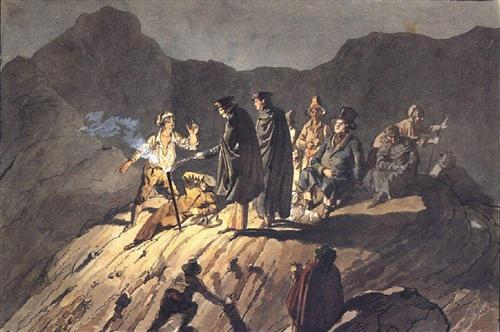Imagine this scene is part of a larger narrative. How would you continue the story? In the aftermath of their confrontation, a pact is formed between the conflicting parties, pledging to work together to uncover the secrets hidden within the rocky cliff. Sir Nathaniel leads the group into an expansive cavern, its entrance concealed by years of erosion. Torches flicker against the damp walls as they delve deeper, revealing ancient carvings and long-forgotten treasure troves. However, as they progress, they face a series of challenges: collapsing tunnels, subterranean monsters awakened from their slumber, and ancient curses guarding the treasures. The journey tests their resolve, alliances are strained, and some pay a high price for the pursuit of knowledge and wealth. In the end, the survivors emerge from the depths, irrevocably changed by their odyssey. They carry with them not just material riches, but also profound insights into their own humanity and the intricate tapestry of history they’ve unraveled. 